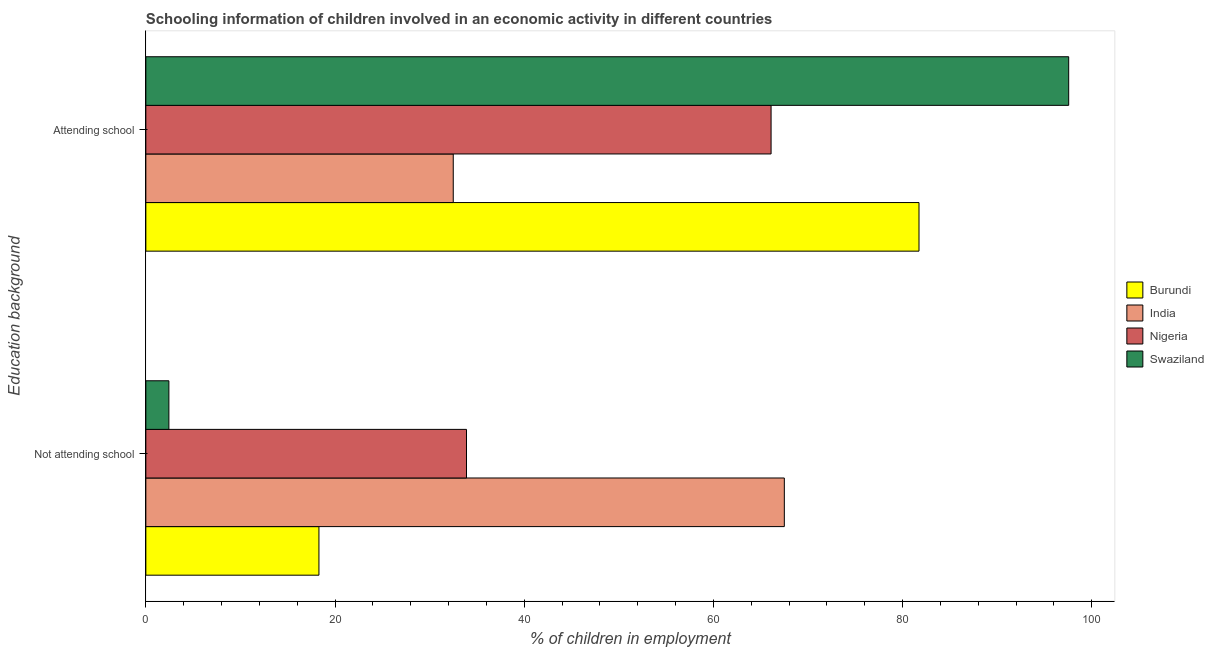How many different coloured bars are there?
Your response must be concise. 4. Are the number of bars per tick equal to the number of legend labels?
Offer a very short reply. Yes. How many bars are there on the 1st tick from the top?
Make the answer very short. 4. What is the label of the 1st group of bars from the top?
Provide a short and direct response. Attending school. What is the percentage of employed children who are attending school in India?
Offer a very short reply. 32.5. Across all countries, what is the maximum percentage of employed children who are not attending school?
Your answer should be compact. 67.5. Across all countries, what is the minimum percentage of employed children who are attending school?
Provide a short and direct response. 32.5. In which country was the percentage of employed children who are not attending school maximum?
Your answer should be compact. India. In which country was the percentage of employed children who are not attending school minimum?
Keep it short and to the point. Swaziland. What is the total percentage of employed children who are not attending school in the graph?
Keep it short and to the point. 122.14. What is the difference between the percentage of employed children who are attending school in Swaziland and that in Burundi?
Offer a terse response. 15.82. What is the difference between the percentage of employed children who are attending school in Burundi and the percentage of employed children who are not attending school in Nigeria?
Offer a very short reply. 47.84. What is the average percentage of employed children who are attending school per country?
Keep it short and to the point. 69.48. What is the difference between the percentage of employed children who are not attending school and percentage of employed children who are attending school in Swaziland?
Ensure brevity in your answer.  -95.13. What is the ratio of the percentage of employed children who are not attending school in India to that in Burundi?
Provide a short and direct response. 3.69. In how many countries, is the percentage of employed children who are not attending school greater than the average percentage of employed children who are not attending school taken over all countries?
Offer a terse response. 2. What does the 1st bar from the top in Not attending school represents?
Offer a terse response. Swaziland. What does the 4th bar from the bottom in Attending school represents?
Your response must be concise. Swaziland. Are all the bars in the graph horizontal?
Offer a terse response. Yes. How many countries are there in the graph?
Your answer should be very brief. 4. What is the difference between two consecutive major ticks on the X-axis?
Keep it short and to the point. 20. Are the values on the major ticks of X-axis written in scientific E-notation?
Provide a succinct answer. No. Does the graph contain any zero values?
Give a very brief answer. No. Where does the legend appear in the graph?
Provide a succinct answer. Center right. How many legend labels are there?
Provide a succinct answer. 4. What is the title of the graph?
Provide a succinct answer. Schooling information of children involved in an economic activity in different countries. What is the label or title of the X-axis?
Your answer should be very brief. % of children in employment. What is the label or title of the Y-axis?
Provide a short and direct response. Education background. What is the % of children in employment in Burundi in Not attending school?
Give a very brief answer. 18.3. What is the % of children in employment in India in Not attending school?
Offer a very short reply. 67.5. What is the % of children in employment of Nigeria in Not attending school?
Give a very brief answer. 33.9. What is the % of children in employment of Swaziland in Not attending school?
Offer a very short reply. 2.44. What is the % of children in employment of Burundi in Attending school?
Ensure brevity in your answer.  81.74. What is the % of children in employment of India in Attending school?
Offer a terse response. 32.5. What is the % of children in employment in Nigeria in Attending school?
Provide a short and direct response. 66.1. What is the % of children in employment of Swaziland in Attending school?
Your answer should be compact. 97.56. Across all Education background, what is the maximum % of children in employment of Burundi?
Your answer should be compact. 81.74. Across all Education background, what is the maximum % of children in employment of India?
Give a very brief answer. 67.5. Across all Education background, what is the maximum % of children in employment of Nigeria?
Ensure brevity in your answer.  66.1. Across all Education background, what is the maximum % of children in employment of Swaziland?
Offer a terse response. 97.56. Across all Education background, what is the minimum % of children in employment of Burundi?
Ensure brevity in your answer.  18.3. Across all Education background, what is the minimum % of children in employment of India?
Give a very brief answer. 32.5. Across all Education background, what is the minimum % of children in employment of Nigeria?
Your answer should be compact. 33.9. Across all Education background, what is the minimum % of children in employment in Swaziland?
Your response must be concise. 2.44. What is the total % of children in employment in Burundi in the graph?
Your answer should be compact. 100.04. What is the difference between the % of children in employment of Burundi in Not attending school and that in Attending school?
Your answer should be compact. -63.44. What is the difference between the % of children in employment in Nigeria in Not attending school and that in Attending school?
Your response must be concise. -32.2. What is the difference between the % of children in employment of Swaziland in Not attending school and that in Attending school?
Offer a very short reply. -95.13. What is the difference between the % of children in employment in Burundi in Not attending school and the % of children in employment in Nigeria in Attending school?
Offer a very short reply. -47.8. What is the difference between the % of children in employment in Burundi in Not attending school and the % of children in employment in Swaziland in Attending school?
Make the answer very short. -79.26. What is the difference between the % of children in employment of India in Not attending school and the % of children in employment of Nigeria in Attending school?
Give a very brief answer. 1.4. What is the difference between the % of children in employment in India in Not attending school and the % of children in employment in Swaziland in Attending school?
Provide a succinct answer. -30.06. What is the difference between the % of children in employment in Nigeria in Not attending school and the % of children in employment in Swaziland in Attending school?
Your answer should be compact. -63.66. What is the average % of children in employment of Burundi per Education background?
Provide a short and direct response. 50.02. What is the average % of children in employment of India per Education background?
Your answer should be compact. 50. What is the average % of children in employment of Swaziland per Education background?
Make the answer very short. 50. What is the difference between the % of children in employment of Burundi and % of children in employment of India in Not attending school?
Offer a terse response. -49.2. What is the difference between the % of children in employment in Burundi and % of children in employment in Nigeria in Not attending school?
Give a very brief answer. -15.6. What is the difference between the % of children in employment of Burundi and % of children in employment of Swaziland in Not attending school?
Keep it short and to the point. 15.86. What is the difference between the % of children in employment of India and % of children in employment of Nigeria in Not attending school?
Give a very brief answer. 33.6. What is the difference between the % of children in employment of India and % of children in employment of Swaziland in Not attending school?
Your answer should be very brief. 65.06. What is the difference between the % of children in employment of Nigeria and % of children in employment of Swaziland in Not attending school?
Provide a succinct answer. 31.46. What is the difference between the % of children in employment in Burundi and % of children in employment in India in Attending school?
Keep it short and to the point. 49.24. What is the difference between the % of children in employment in Burundi and % of children in employment in Nigeria in Attending school?
Offer a terse response. 15.64. What is the difference between the % of children in employment of Burundi and % of children in employment of Swaziland in Attending school?
Make the answer very short. -15.82. What is the difference between the % of children in employment in India and % of children in employment in Nigeria in Attending school?
Offer a very short reply. -33.6. What is the difference between the % of children in employment in India and % of children in employment in Swaziland in Attending school?
Ensure brevity in your answer.  -65.06. What is the difference between the % of children in employment of Nigeria and % of children in employment of Swaziland in Attending school?
Keep it short and to the point. -31.46. What is the ratio of the % of children in employment in Burundi in Not attending school to that in Attending school?
Make the answer very short. 0.22. What is the ratio of the % of children in employment in India in Not attending school to that in Attending school?
Your answer should be compact. 2.08. What is the ratio of the % of children in employment of Nigeria in Not attending school to that in Attending school?
Your answer should be very brief. 0.51. What is the ratio of the % of children in employment in Swaziland in Not attending school to that in Attending school?
Offer a terse response. 0.03. What is the difference between the highest and the second highest % of children in employment of Burundi?
Your answer should be very brief. 63.44. What is the difference between the highest and the second highest % of children in employment in Nigeria?
Your response must be concise. 32.2. What is the difference between the highest and the second highest % of children in employment in Swaziland?
Keep it short and to the point. 95.13. What is the difference between the highest and the lowest % of children in employment in Burundi?
Your answer should be very brief. 63.44. What is the difference between the highest and the lowest % of children in employment in Nigeria?
Offer a terse response. 32.2. What is the difference between the highest and the lowest % of children in employment in Swaziland?
Provide a succinct answer. 95.13. 